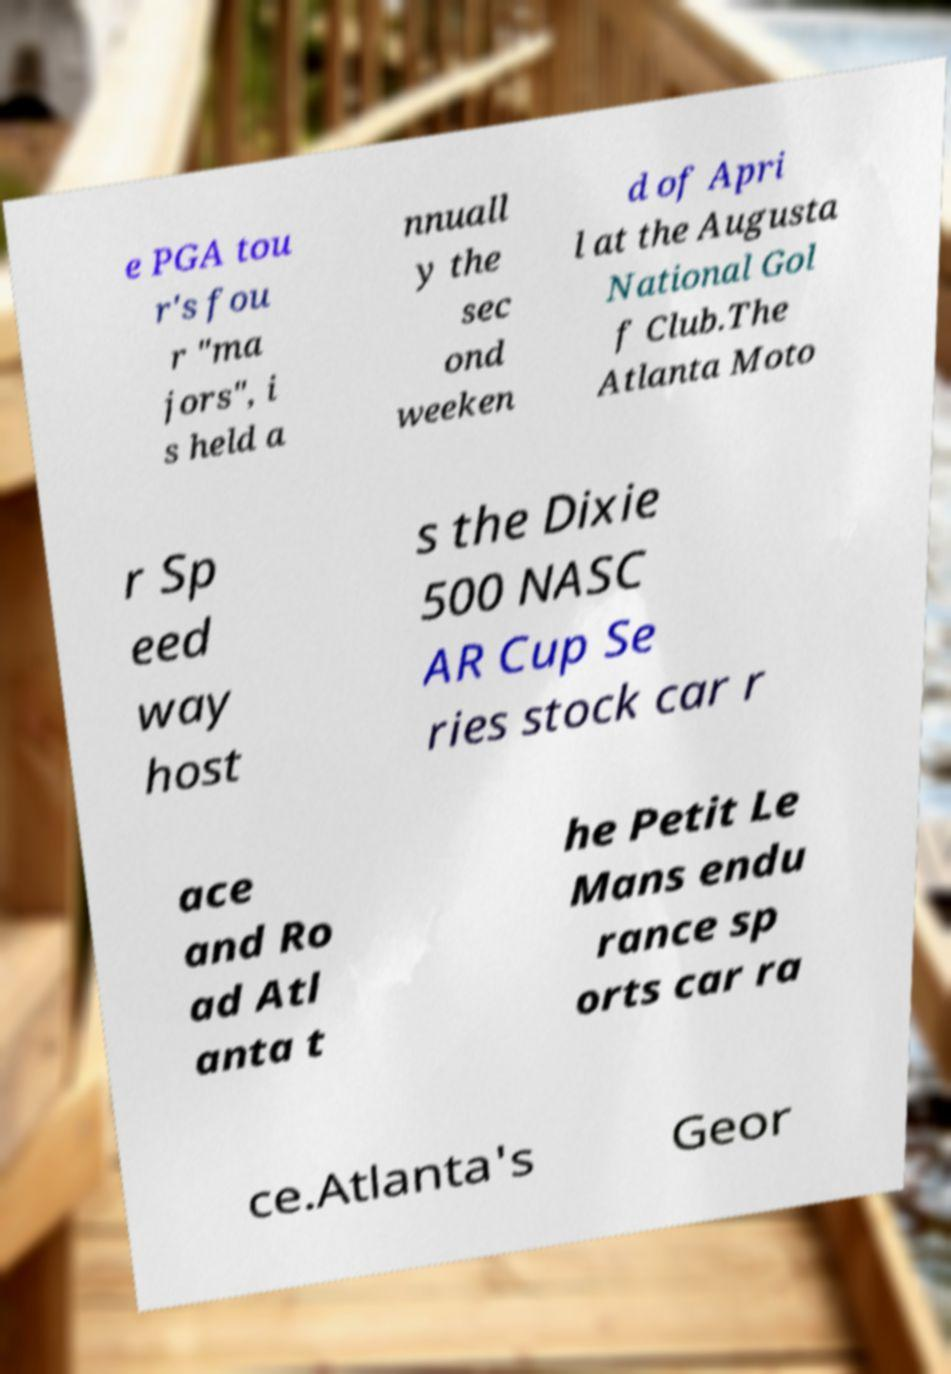Can you accurately transcribe the text from the provided image for me? e PGA tou r's fou r "ma jors", i s held a nnuall y the sec ond weeken d of Apri l at the Augusta National Gol f Club.The Atlanta Moto r Sp eed way host s the Dixie 500 NASC AR Cup Se ries stock car r ace and Ro ad Atl anta t he Petit Le Mans endu rance sp orts car ra ce.Atlanta's Geor 